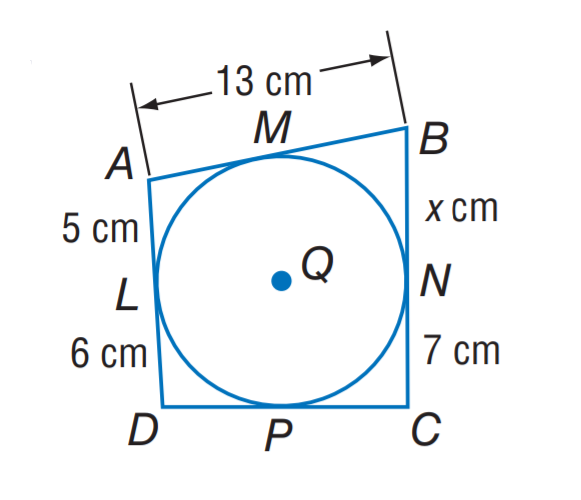Question: Find x.
Choices:
A. 7
B. 8
C. 11
D. 13
Answer with the letter. Answer: B 